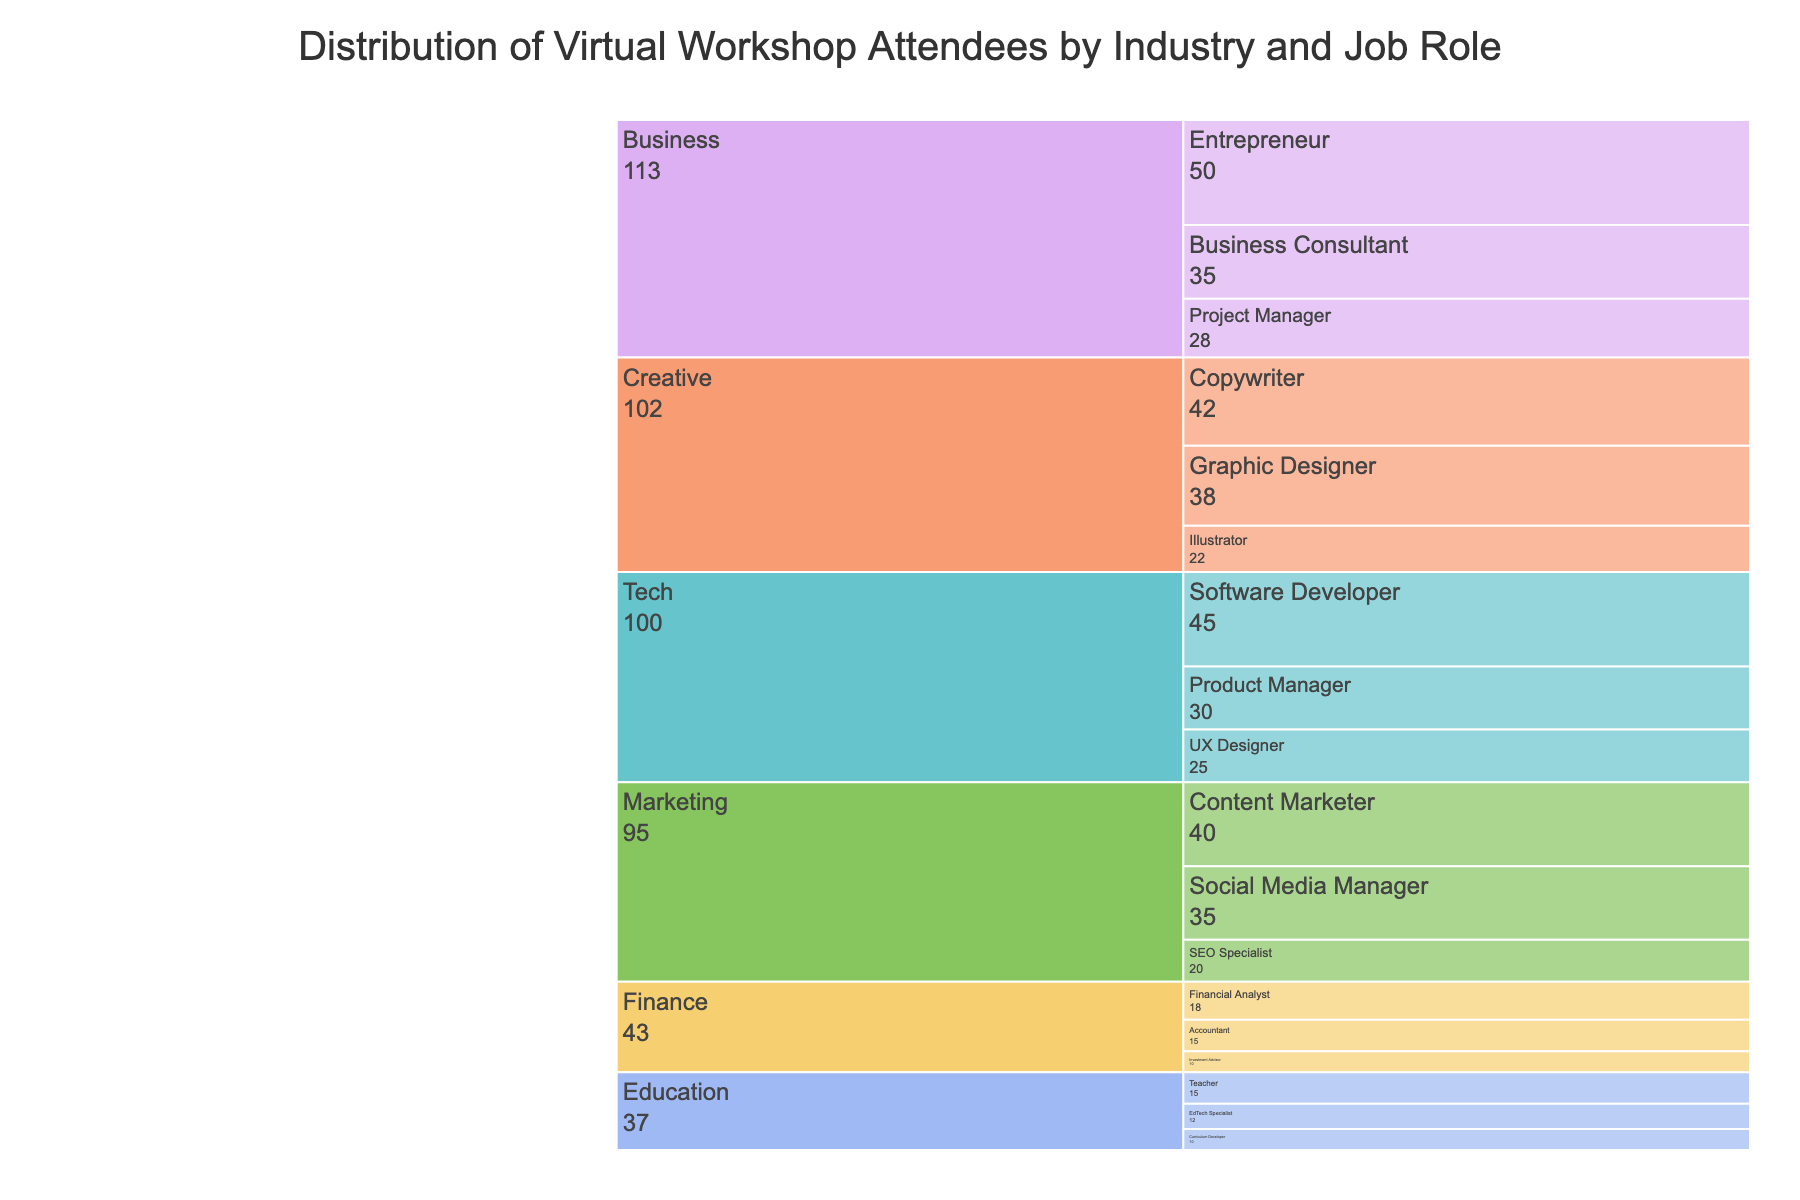What is the title of the figure? The title of the figure is usually placed at the top-center of the visualization and provides the main heading or summative description of the data presented. In this case, the title conveys the context of the chart.
Answer: Distribution of Virtual Workshop Attendees by Industry and Job Role How many attendees are there in the Tech industry? To determine the attendees in the Tech industry, sum the number of attendees for each job role within the Tech industry. Tech includes Software Developer (45), Product Manager (30), and UX Designer (25). Adding these together gives 45 + 30 + 25.
Answer: 100 Which industry has the largest number of total attendees? By summing the number of attendees for each job role within each industry, we compare the totals. The industry with the highest total will be the answer. Business has Entrepreneur (50), Business Consultant (35), and Project Manager (28), which totals 113. This is the highest total compared to the other industries.
Answer: Business Which job role within the Creative industry has the highest number of attendees? By examining the job roles under the Creative industry, we see that there are Graphic Designer, Copywriter, and Illustrator. We compare their attendee counts: Graphic Designer (38), Copywriter (42), and Illustrator (22). The highest number is for Copywriter.
Answer: Copywriter What is the combined number of attendees from the Entrepreneur and Business Consultant roles? To find the combined number of attendees, sum the attendees for Entrepreneur (50) and Business Consultant (35), which gives 50 + 35.
Answer: 85 Which job role has the smallest number of attendees in the Education industry? By looking at the job roles under the Education industry, we compare the attendee numbers for Teacher (15), EdTech Specialist (12), and Curriculum Developer (10). The smallest number is for Curriculum Developer.
Answer: Curriculum Developer Compare the total number of attendees in the Finance industry to the total number of attendees in the Marketing industry. Which is higher and by how much? Summing the attendees in each industry: Finance has Financial Analyst (18), Accountant (15), and Investment Advisor (10), totaling 43. Marketing has Content Marketer (40), Social Media Manager (35), and SEO Specialist (20), totaling 95. The difference is 95 - 43. Marketing is higher by 52.
Answer: Marketing by 52  To determine the difference in attendees between the Content Marketer and SEO Specialist roles in the Marketing industry, subtract the number of SEO Specialist attendees (20) from the number of Content Marketer attendees (40). This gives 40 - 20.
Answer: 20 Which industry, other than Business, has the highest overall number of attendees? By calculating the total number of attendees for each industry and excluding Business, we compare the results. Tech has 100, Marketing has 95, Creative has 102, Education has 37, and Finance has 43. Creative, with 105, has the highest number excluding Business.
Answer: Creative What is the total number of attendees across all industries? To find the total number of attendees, sum the attendees across all job roles and industries. Adding all values from the data: 492.
Answer: 492 